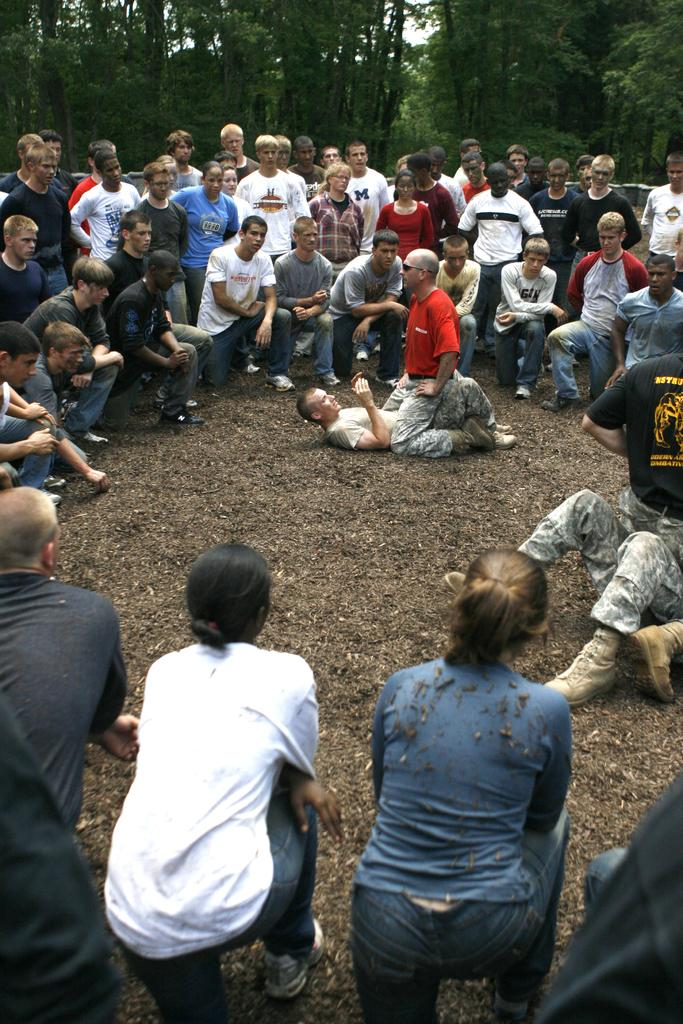How many persons are lying down in the image? There are two persons lying down in the image. How many persons are on their knees in the image? There are two persons on their knees in the image. What can be seen in the background of the image? There is a group of people standing in the background of the image. What type of vegetation is visible in the image? There are trees visible in the image. What is visible at the top of the image? The sky is visible at the top of the image. What type of nut is being sold at the store in the image? There is no store present in the image, and therefore no nuts are being sold. What kind of trouble are the two persons lying down experiencing in the image? There is no indication of trouble in the image; the two persons are simply lying down. 